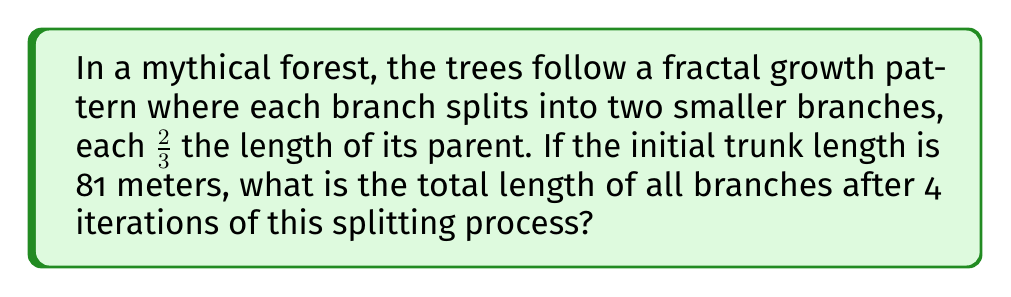Solve this math problem. Let's approach this step-by-step:

1) First, let's define our variables:
   $L_0 = 81$ meters (initial trunk length)
   $r = 2/3$ (ratio of child branch to parent branch length)
   $n = 4$ (number of iterations)

2) In each iteration, the number of branches doubles:
   Iteration 0: 1 branch
   Iteration 1: 2 branches
   Iteration 2: 4 branches
   Iteration 3: 8 branches
   Iteration 4: 16 branches

3) The length of each branch at iteration $i$ is:
   $L_i = L_0 \cdot r^i$

4) The total length at each iteration is the number of branches multiplied by their length:
   Iteration 0: $1 \cdot L_0 = 81$
   Iteration 1: $2 \cdot L_0 \cdot r = 2 \cdot 81 \cdot (2/3) = 108$
   Iteration 2: $4 \cdot L_0 \cdot r^2 = 4 \cdot 81 \cdot (2/3)^2 = 144$
   Iteration 3: $8 \cdot L_0 \cdot r^3 = 8 \cdot 81 \cdot (2/3)^3 = 192$
   Iteration 4: $16 \cdot L_0 \cdot r^4 = 16 \cdot 81 \cdot (2/3)^4 = 256$

5) The total length of all branches is the sum of these:
   $Total = 81 + 108 + 144 + 192 + 256 = 781$

Therefore, the total length of all branches after 4 iterations is 781 meters.
Answer: 781 meters 